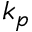Convert formula to latex. <formula><loc_0><loc_0><loc_500><loc_500>k _ { p }</formula> 